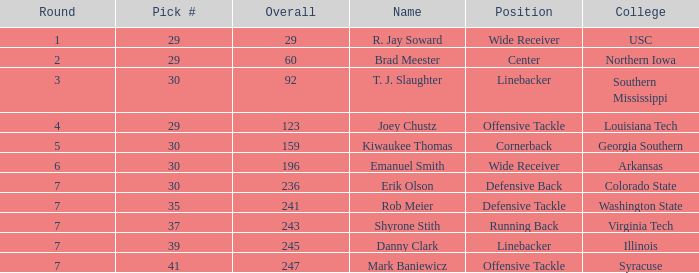What is the smallest round with a sum of 247 and a choice below 41? None. 